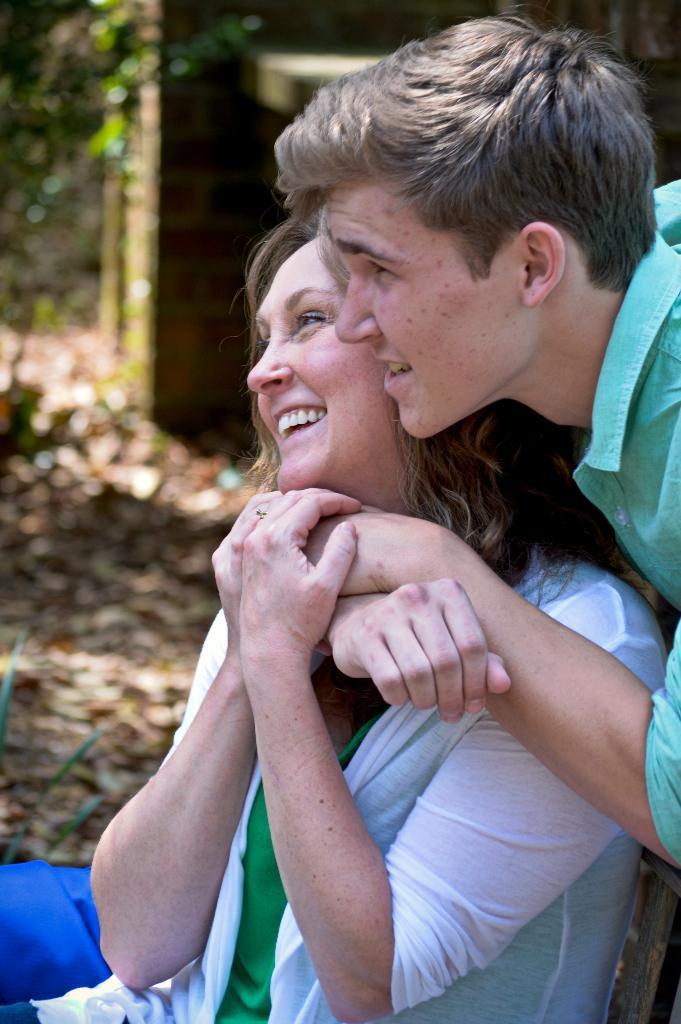How would you summarize this image in a sentence or two? In this image there is a person holding another person, and there is blur background. 